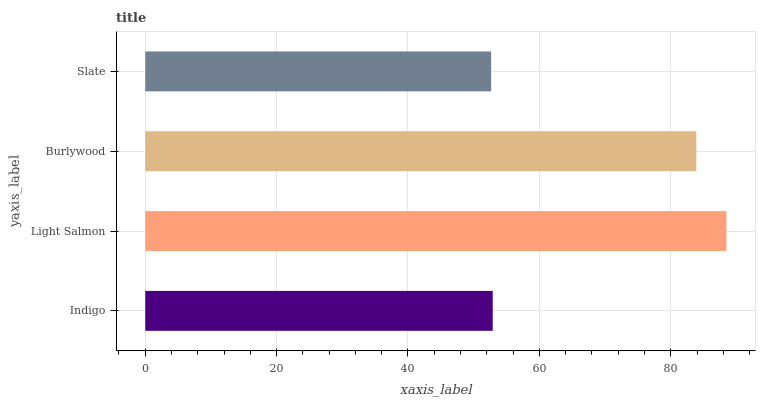Is Slate the minimum?
Answer yes or no. Yes. Is Light Salmon the maximum?
Answer yes or no. Yes. Is Burlywood the minimum?
Answer yes or no. No. Is Burlywood the maximum?
Answer yes or no. No. Is Light Salmon greater than Burlywood?
Answer yes or no. Yes. Is Burlywood less than Light Salmon?
Answer yes or no. Yes. Is Burlywood greater than Light Salmon?
Answer yes or no. No. Is Light Salmon less than Burlywood?
Answer yes or no. No. Is Burlywood the high median?
Answer yes or no. Yes. Is Indigo the low median?
Answer yes or no. Yes. Is Light Salmon the high median?
Answer yes or no. No. Is Slate the low median?
Answer yes or no. No. 